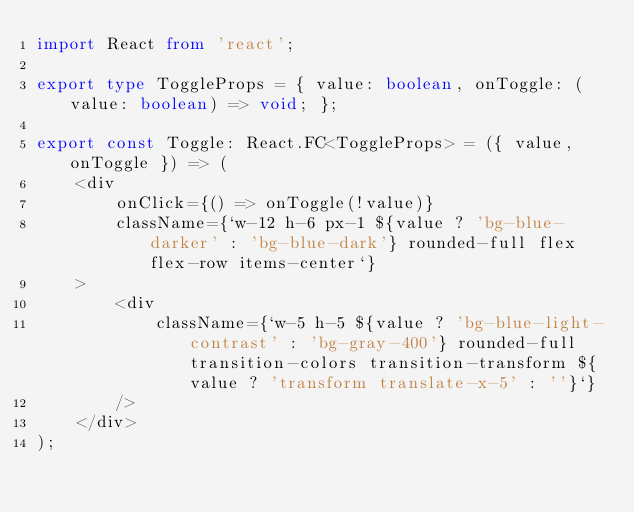Convert code to text. <code><loc_0><loc_0><loc_500><loc_500><_TypeScript_>import React from 'react';

export type ToggleProps = { value: boolean, onToggle: (value: boolean) => void; };

export const Toggle: React.FC<ToggleProps> = ({ value, onToggle }) => (
    <div
        onClick={() => onToggle(!value)}
        className={`w-12 h-6 px-1 ${value ? 'bg-blue-darker' : 'bg-blue-dark'} rounded-full flex flex-row items-center`}
    >
        <div
            className={`w-5 h-5 ${value ? 'bg-blue-light-contrast' : 'bg-gray-400'} rounded-full transition-colors transition-transform ${value ? 'transform translate-x-5' : ''}`}
        />
    </div>
);
</code> 